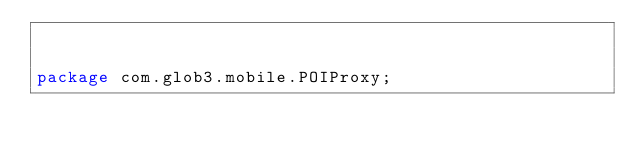Convert code to text. <code><loc_0><loc_0><loc_500><loc_500><_Java_>

package com.glob3.mobile.POIProxy;
</code> 